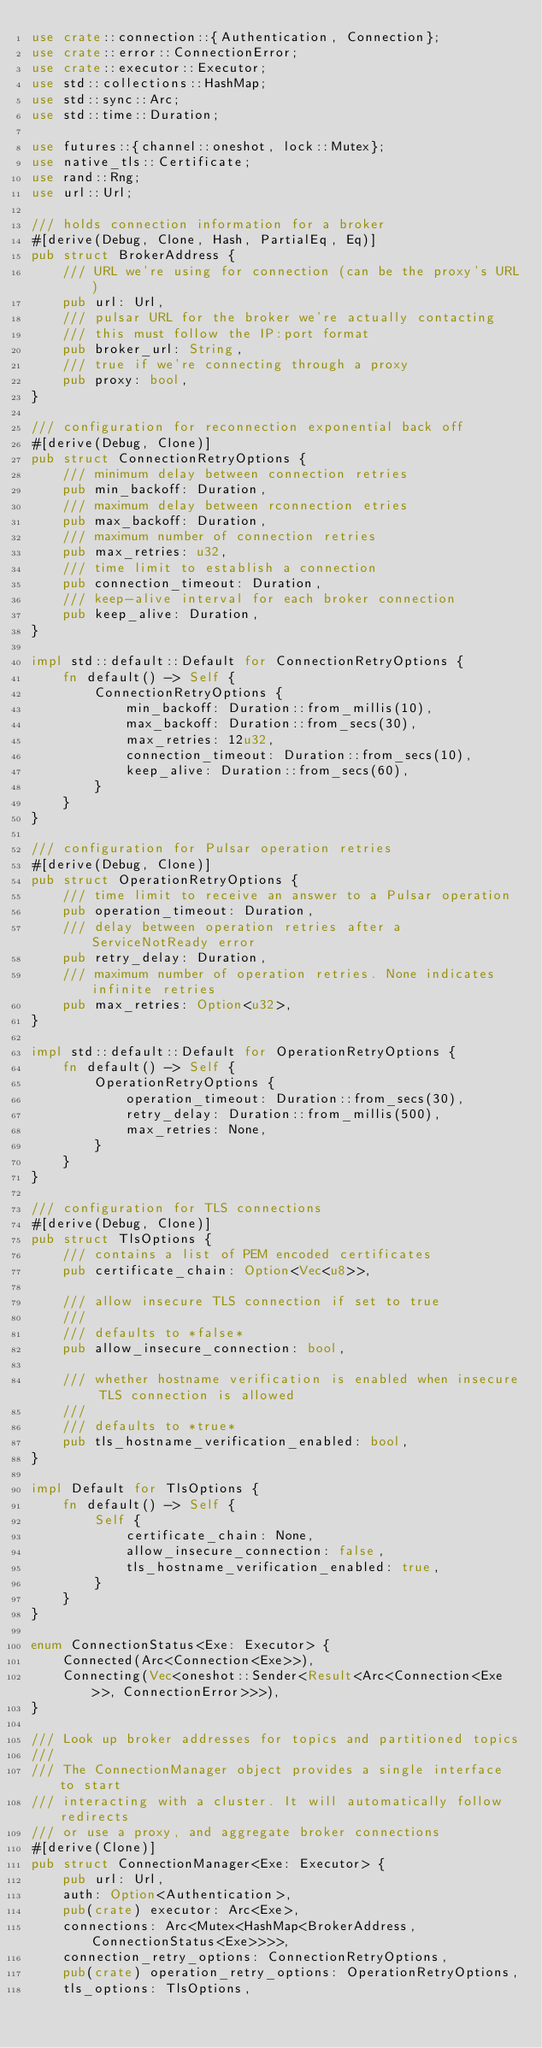<code> <loc_0><loc_0><loc_500><loc_500><_Rust_>use crate::connection::{Authentication, Connection};
use crate::error::ConnectionError;
use crate::executor::Executor;
use std::collections::HashMap;
use std::sync::Arc;
use std::time::Duration;

use futures::{channel::oneshot, lock::Mutex};
use native_tls::Certificate;
use rand::Rng;
use url::Url;

/// holds connection information for a broker
#[derive(Debug, Clone, Hash, PartialEq, Eq)]
pub struct BrokerAddress {
    /// URL we're using for connection (can be the proxy's URL)
    pub url: Url,
    /// pulsar URL for the broker we're actually contacting
    /// this must follow the IP:port format
    pub broker_url: String,
    /// true if we're connecting through a proxy
    pub proxy: bool,
}

/// configuration for reconnection exponential back off
#[derive(Debug, Clone)]
pub struct ConnectionRetryOptions {
    /// minimum delay between connection retries
    pub min_backoff: Duration,
    /// maximum delay between rconnection etries
    pub max_backoff: Duration,
    /// maximum number of connection retries
    pub max_retries: u32,
    /// time limit to establish a connection
    pub connection_timeout: Duration,
    /// keep-alive interval for each broker connection
    pub keep_alive: Duration,
}

impl std::default::Default for ConnectionRetryOptions {
    fn default() -> Self {
        ConnectionRetryOptions {
            min_backoff: Duration::from_millis(10),
            max_backoff: Duration::from_secs(30),
            max_retries: 12u32,
            connection_timeout: Duration::from_secs(10),
            keep_alive: Duration::from_secs(60),
        }
    }
}

/// configuration for Pulsar operation retries
#[derive(Debug, Clone)]
pub struct OperationRetryOptions {
    /// time limit to receive an answer to a Pulsar operation
    pub operation_timeout: Duration,
    /// delay between operation retries after a ServiceNotReady error
    pub retry_delay: Duration,
    /// maximum number of operation retries. None indicates infinite retries
    pub max_retries: Option<u32>,
}

impl std::default::Default for OperationRetryOptions {
    fn default() -> Self {
        OperationRetryOptions {
            operation_timeout: Duration::from_secs(30),
            retry_delay: Duration::from_millis(500),
            max_retries: None,
        }
    }
}

/// configuration for TLS connections
#[derive(Debug, Clone)]
pub struct TlsOptions {
    /// contains a list of PEM encoded certificates
    pub certificate_chain: Option<Vec<u8>>,

    /// allow insecure TLS connection if set to true
    ///
    /// defaults to *false*
    pub allow_insecure_connection: bool,

    /// whether hostname verification is enabled when insecure TLS connection is allowed
    ///
    /// defaults to *true*
    pub tls_hostname_verification_enabled: bool,
}

impl Default for TlsOptions {
    fn default() -> Self {
        Self {
            certificate_chain: None,
            allow_insecure_connection: false,
            tls_hostname_verification_enabled: true,
        }
    }
}

enum ConnectionStatus<Exe: Executor> {
    Connected(Arc<Connection<Exe>>),
    Connecting(Vec<oneshot::Sender<Result<Arc<Connection<Exe>>, ConnectionError>>>),
}

/// Look up broker addresses for topics and partitioned topics
///
/// The ConnectionManager object provides a single interface to start
/// interacting with a cluster. It will automatically follow redirects
/// or use a proxy, and aggregate broker connections
#[derive(Clone)]
pub struct ConnectionManager<Exe: Executor> {
    pub url: Url,
    auth: Option<Authentication>,
    pub(crate) executor: Arc<Exe>,
    connections: Arc<Mutex<HashMap<BrokerAddress, ConnectionStatus<Exe>>>>,
    connection_retry_options: ConnectionRetryOptions,
    pub(crate) operation_retry_options: OperationRetryOptions,
    tls_options: TlsOptions,</code> 